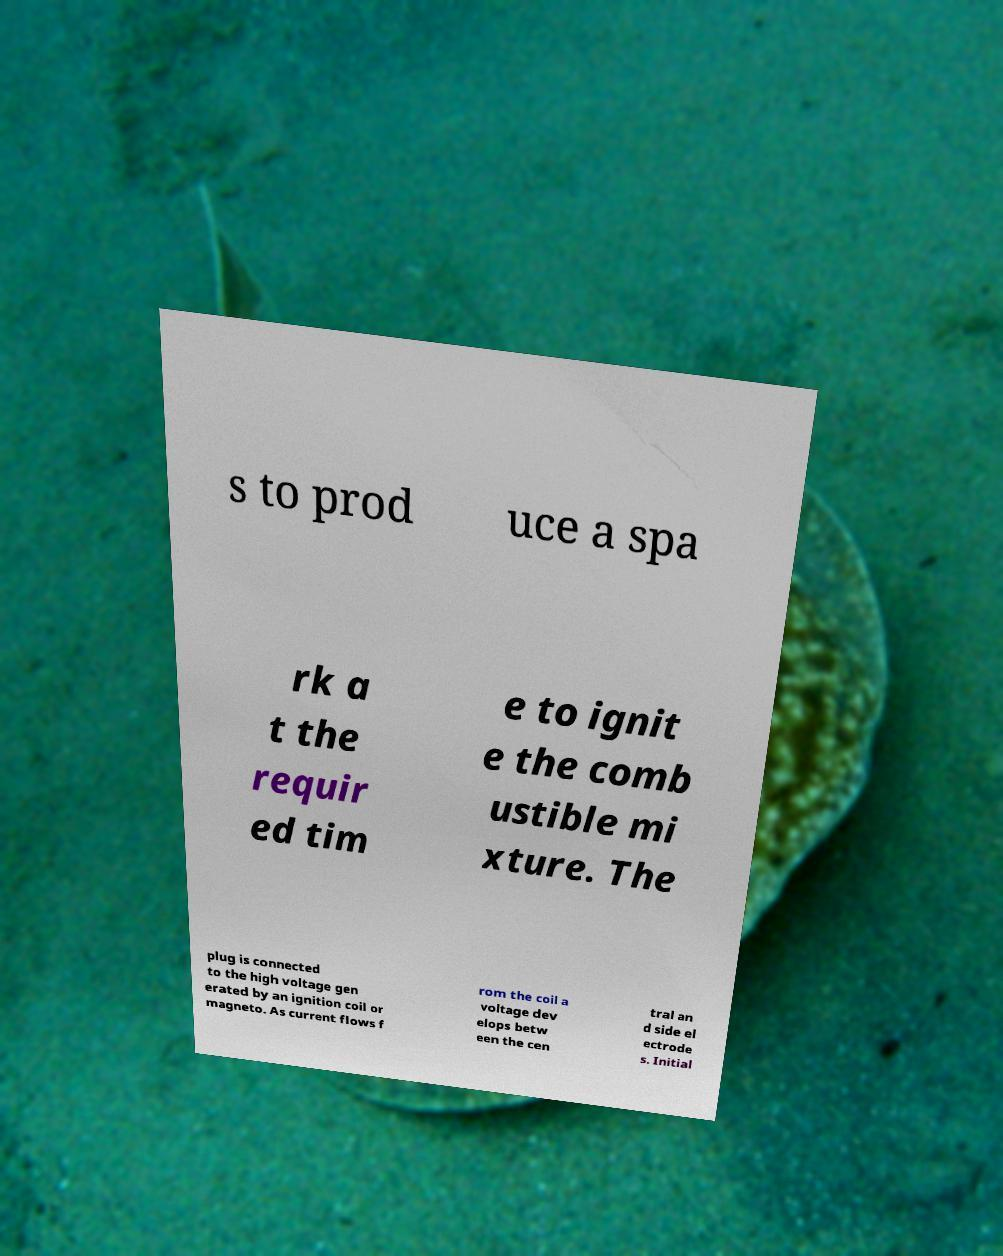Please read and relay the text visible in this image. What does it say? s to prod uce a spa rk a t the requir ed tim e to ignit e the comb ustible mi xture. The plug is connected to the high voltage gen erated by an ignition coil or magneto. As current flows f rom the coil a voltage dev elops betw een the cen tral an d side el ectrode s. Initial 